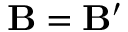Convert formula to latex. <formula><loc_0><loc_0><loc_500><loc_500>B = B ^ { \prime }</formula> 